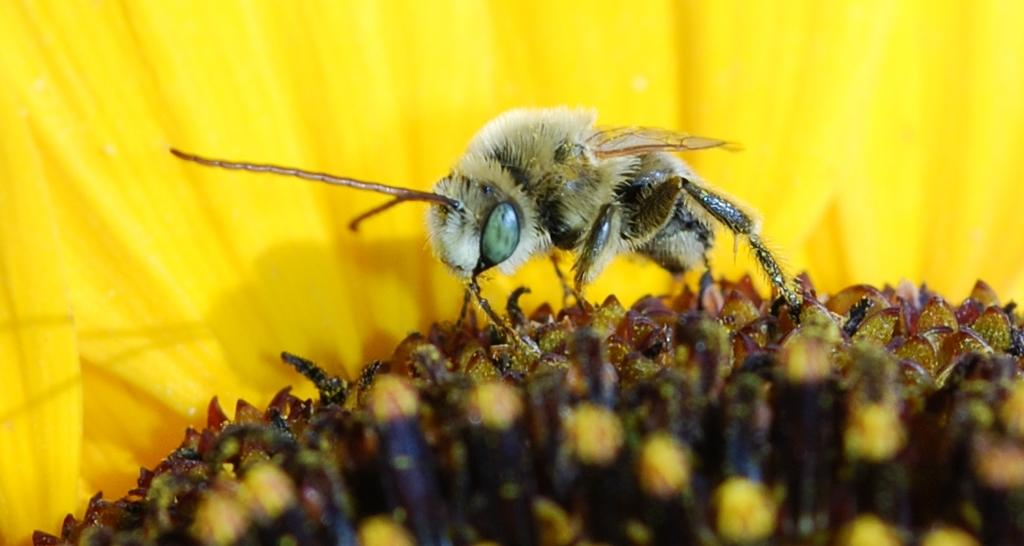What type of plant can be seen in the image? There is a flower in the image. What other living organism is present in the image? There is an insect in the image. What type of process is the flower undergoing in the image? The flower is not undergoing any specific process in the image; it is simply depicted as a static image. What type of jewel can be seen on the insect in the image? There is no jewel present on the insect in the image. 